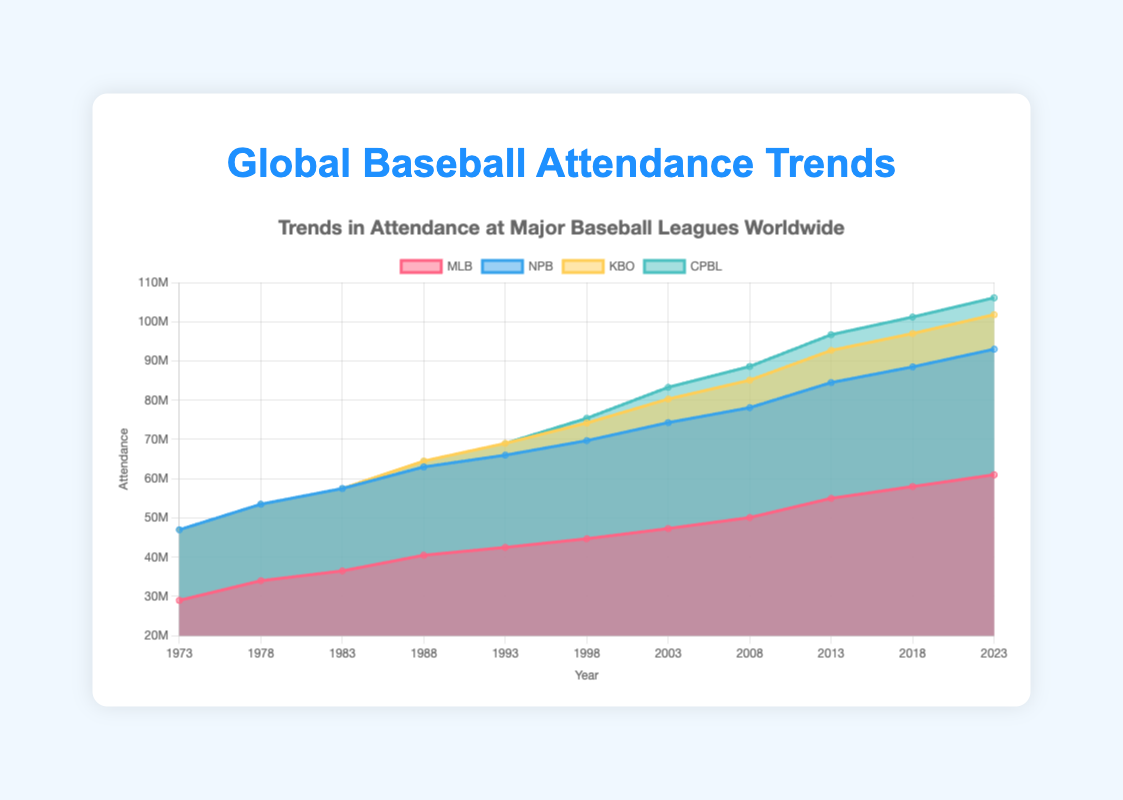What is the title of the chart? The title of the chart is located at the top center, which reads "Trends in Attendance at Major Baseball Leagues Worldwide".
Answer: Trends in Attendance at Major Baseball Leagues Worldwide How many leagues are represented in this chart? By looking at the legend at the top, we can see that there are four leagues represented: MLB, NPB, KBO, and CPBL.
Answer: Four Which league had the highest attendance in 2023? From the height of the areas corresponding to each league, we can see that MLB has the highest attendance in 2023.
Answer: MLB When did the CPBL first start showing attendance in the chart? Examining the area for CPBL, we can see that attendance data appears starting from the year 1998.
Answer: 1998 How did the attendance of KBO change from 1993 to 2023? KBO had no attendance data up to 1993. Starting from 1993, attendance gradually increased, reaching about 8.8 million in 2023.
Answer: Increased to 8.8 million What is the difference in attendance between NPB and KBO in 2023? In 2023, NPB's attendance is 32 million and KBO's attendance is 8.8 million. The difference is 32 million - 8.8 million = 23.2 million.
Answer: 23.2 million Between which years did MLB see the most significant rise in attendance? By analyzing the graph, the greatest rise in MLB attendance seems to occur between 2008 and 2013, where it increased from 50.1 million to 55 million.
Answer: 2008 to 2013 Which league shows the most consistent growth over the years? By observing the steady increase in the area size across years, NPB shows the most consistent growth in attendance from 1973 to 2023.
Answer: NPB What is the total combined attendance of all leagues in 2023? Adding the values for all leagues in 2023: MLB (61 million) + NPB (32 million) + KBO (8.8 million) + CPBL (4.3 million) = 106.1 million.
Answer: 106.1 million 